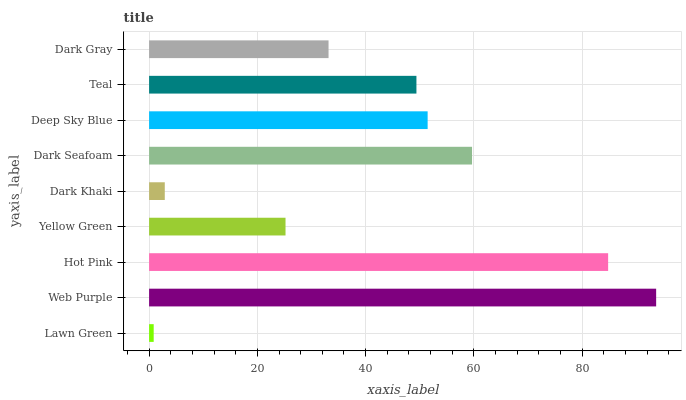Is Lawn Green the minimum?
Answer yes or no. Yes. Is Web Purple the maximum?
Answer yes or no. Yes. Is Hot Pink the minimum?
Answer yes or no. No. Is Hot Pink the maximum?
Answer yes or no. No. Is Web Purple greater than Hot Pink?
Answer yes or no. Yes. Is Hot Pink less than Web Purple?
Answer yes or no. Yes. Is Hot Pink greater than Web Purple?
Answer yes or no. No. Is Web Purple less than Hot Pink?
Answer yes or no. No. Is Teal the high median?
Answer yes or no. Yes. Is Teal the low median?
Answer yes or no. Yes. Is Dark Gray the high median?
Answer yes or no. No. Is Dark Gray the low median?
Answer yes or no. No. 